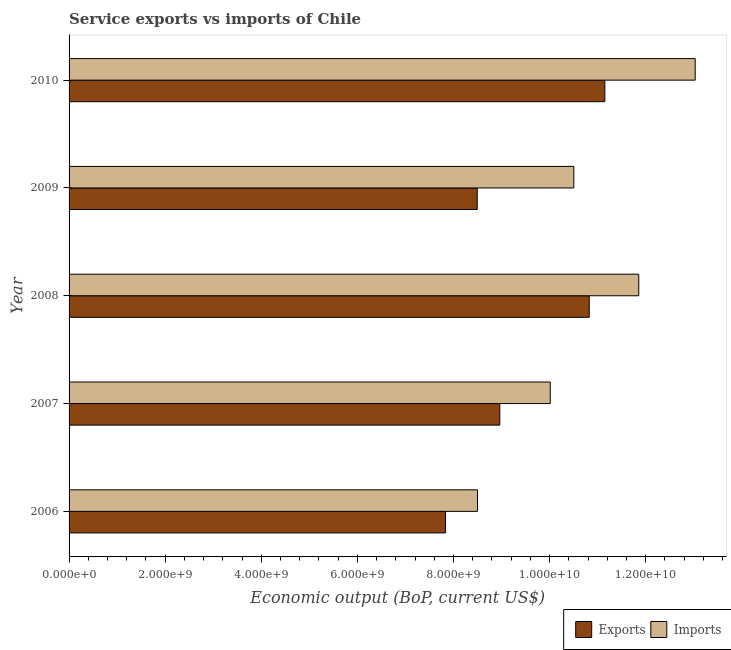Are the number of bars per tick equal to the number of legend labels?
Your response must be concise. Yes. What is the label of the 4th group of bars from the top?
Provide a succinct answer. 2007. What is the amount of service imports in 2007?
Your response must be concise. 1.00e+1. Across all years, what is the maximum amount of service exports?
Keep it short and to the point. 1.11e+1. Across all years, what is the minimum amount of service imports?
Offer a very short reply. 8.50e+09. In which year was the amount of service imports minimum?
Make the answer very short. 2006. What is the total amount of service imports in the graph?
Provide a short and direct response. 5.39e+1. What is the difference between the amount of service imports in 2006 and that in 2007?
Ensure brevity in your answer.  -1.51e+09. What is the difference between the amount of service exports in 2008 and the amount of service imports in 2007?
Your answer should be compact. 8.11e+08. What is the average amount of service exports per year?
Offer a terse response. 9.45e+09. In the year 2009, what is the difference between the amount of service exports and amount of service imports?
Keep it short and to the point. -2.01e+09. What is the ratio of the amount of service exports in 2009 to that in 2010?
Make the answer very short. 0.76. Is the amount of service imports in 2008 less than that in 2010?
Give a very brief answer. Yes. What is the difference between the highest and the second highest amount of service exports?
Provide a succinct answer. 3.25e+08. What is the difference between the highest and the lowest amount of service exports?
Keep it short and to the point. 3.32e+09. In how many years, is the amount of service imports greater than the average amount of service imports taken over all years?
Provide a succinct answer. 2. Is the sum of the amount of service imports in 2008 and 2009 greater than the maximum amount of service exports across all years?
Your response must be concise. Yes. What does the 2nd bar from the top in 2007 represents?
Offer a very short reply. Exports. What does the 1st bar from the bottom in 2008 represents?
Ensure brevity in your answer.  Exports. How many bars are there?
Your answer should be very brief. 10. What is the difference between two consecutive major ticks on the X-axis?
Your response must be concise. 2.00e+09. Does the graph contain any zero values?
Ensure brevity in your answer.  No. Where does the legend appear in the graph?
Your answer should be compact. Bottom right. What is the title of the graph?
Provide a succinct answer. Service exports vs imports of Chile. What is the label or title of the X-axis?
Your response must be concise. Economic output (BoP, current US$). What is the Economic output (BoP, current US$) of Exports in 2006?
Your response must be concise. 7.83e+09. What is the Economic output (BoP, current US$) of Imports in 2006?
Keep it short and to the point. 8.50e+09. What is the Economic output (BoP, current US$) of Exports in 2007?
Your answer should be compact. 8.96e+09. What is the Economic output (BoP, current US$) in Imports in 2007?
Your response must be concise. 1.00e+1. What is the Economic output (BoP, current US$) in Exports in 2008?
Offer a terse response. 1.08e+1. What is the Economic output (BoP, current US$) in Imports in 2008?
Your answer should be compact. 1.19e+1. What is the Economic output (BoP, current US$) of Exports in 2009?
Make the answer very short. 8.49e+09. What is the Economic output (BoP, current US$) of Imports in 2009?
Give a very brief answer. 1.05e+1. What is the Economic output (BoP, current US$) in Exports in 2010?
Offer a very short reply. 1.11e+1. What is the Economic output (BoP, current US$) in Imports in 2010?
Keep it short and to the point. 1.30e+1. Across all years, what is the maximum Economic output (BoP, current US$) in Exports?
Make the answer very short. 1.11e+1. Across all years, what is the maximum Economic output (BoP, current US$) in Imports?
Give a very brief answer. 1.30e+1. Across all years, what is the minimum Economic output (BoP, current US$) of Exports?
Make the answer very short. 7.83e+09. Across all years, what is the minimum Economic output (BoP, current US$) in Imports?
Offer a terse response. 8.50e+09. What is the total Economic output (BoP, current US$) of Exports in the graph?
Provide a short and direct response. 4.73e+1. What is the total Economic output (BoP, current US$) of Imports in the graph?
Your answer should be compact. 5.39e+1. What is the difference between the Economic output (BoP, current US$) of Exports in 2006 and that in 2007?
Your answer should be compact. -1.13e+09. What is the difference between the Economic output (BoP, current US$) of Imports in 2006 and that in 2007?
Provide a succinct answer. -1.51e+09. What is the difference between the Economic output (BoP, current US$) of Exports in 2006 and that in 2008?
Keep it short and to the point. -2.99e+09. What is the difference between the Economic output (BoP, current US$) of Imports in 2006 and that in 2008?
Provide a succinct answer. -3.36e+09. What is the difference between the Economic output (BoP, current US$) in Exports in 2006 and that in 2009?
Give a very brief answer. -6.61e+08. What is the difference between the Economic output (BoP, current US$) of Imports in 2006 and that in 2009?
Offer a terse response. -2.00e+09. What is the difference between the Economic output (BoP, current US$) of Exports in 2006 and that in 2010?
Ensure brevity in your answer.  -3.32e+09. What is the difference between the Economic output (BoP, current US$) of Imports in 2006 and that in 2010?
Your answer should be compact. -4.53e+09. What is the difference between the Economic output (BoP, current US$) in Exports in 2007 and that in 2008?
Keep it short and to the point. -1.86e+09. What is the difference between the Economic output (BoP, current US$) in Imports in 2007 and that in 2008?
Ensure brevity in your answer.  -1.84e+09. What is the difference between the Economic output (BoP, current US$) in Exports in 2007 and that in 2009?
Your response must be concise. 4.70e+08. What is the difference between the Economic output (BoP, current US$) in Imports in 2007 and that in 2009?
Offer a very short reply. -4.91e+08. What is the difference between the Economic output (BoP, current US$) of Exports in 2007 and that in 2010?
Offer a very short reply. -2.19e+09. What is the difference between the Economic output (BoP, current US$) in Imports in 2007 and that in 2010?
Provide a succinct answer. -3.02e+09. What is the difference between the Economic output (BoP, current US$) in Exports in 2008 and that in 2009?
Keep it short and to the point. 2.33e+09. What is the difference between the Economic output (BoP, current US$) of Imports in 2008 and that in 2009?
Keep it short and to the point. 1.35e+09. What is the difference between the Economic output (BoP, current US$) of Exports in 2008 and that in 2010?
Your answer should be compact. -3.25e+08. What is the difference between the Economic output (BoP, current US$) in Imports in 2008 and that in 2010?
Offer a very short reply. -1.17e+09. What is the difference between the Economic output (BoP, current US$) in Exports in 2009 and that in 2010?
Provide a short and direct response. -2.66e+09. What is the difference between the Economic output (BoP, current US$) in Imports in 2009 and that in 2010?
Provide a short and direct response. -2.53e+09. What is the difference between the Economic output (BoP, current US$) in Exports in 2006 and the Economic output (BoP, current US$) in Imports in 2007?
Offer a very short reply. -2.18e+09. What is the difference between the Economic output (BoP, current US$) in Exports in 2006 and the Economic output (BoP, current US$) in Imports in 2008?
Your answer should be very brief. -4.02e+09. What is the difference between the Economic output (BoP, current US$) of Exports in 2006 and the Economic output (BoP, current US$) of Imports in 2009?
Give a very brief answer. -2.67e+09. What is the difference between the Economic output (BoP, current US$) of Exports in 2006 and the Economic output (BoP, current US$) of Imports in 2010?
Provide a succinct answer. -5.20e+09. What is the difference between the Economic output (BoP, current US$) in Exports in 2007 and the Economic output (BoP, current US$) in Imports in 2008?
Offer a very short reply. -2.89e+09. What is the difference between the Economic output (BoP, current US$) of Exports in 2007 and the Economic output (BoP, current US$) of Imports in 2009?
Offer a terse response. -1.54e+09. What is the difference between the Economic output (BoP, current US$) of Exports in 2007 and the Economic output (BoP, current US$) of Imports in 2010?
Provide a short and direct response. -4.07e+09. What is the difference between the Economic output (BoP, current US$) in Exports in 2008 and the Economic output (BoP, current US$) in Imports in 2009?
Provide a succinct answer. 3.21e+08. What is the difference between the Economic output (BoP, current US$) in Exports in 2008 and the Economic output (BoP, current US$) in Imports in 2010?
Give a very brief answer. -2.20e+09. What is the difference between the Economic output (BoP, current US$) in Exports in 2009 and the Economic output (BoP, current US$) in Imports in 2010?
Your answer should be compact. -4.54e+09. What is the average Economic output (BoP, current US$) of Exports per year?
Your answer should be compact. 9.45e+09. What is the average Economic output (BoP, current US$) of Imports per year?
Provide a short and direct response. 1.08e+1. In the year 2006, what is the difference between the Economic output (BoP, current US$) in Exports and Economic output (BoP, current US$) in Imports?
Your response must be concise. -6.66e+08. In the year 2007, what is the difference between the Economic output (BoP, current US$) in Exports and Economic output (BoP, current US$) in Imports?
Ensure brevity in your answer.  -1.05e+09. In the year 2008, what is the difference between the Economic output (BoP, current US$) of Exports and Economic output (BoP, current US$) of Imports?
Offer a terse response. -1.03e+09. In the year 2009, what is the difference between the Economic output (BoP, current US$) of Exports and Economic output (BoP, current US$) of Imports?
Your response must be concise. -2.01e+09. In the year 2010, what is the difference between the Economic output (BoP, current US$) in Exports and Economic output (BoP, current US$) in Imports?
Keep it short and to the point. -1.88e+09. What is the ratio of the Economic output (BoP, current US$) in Exports in 2006 to that in 2007?
Offer a terse response. 0.87. What is the ratio of the Economic output (BoP, current US$) in Imports in 2006 to that in 2007?
Your answer should be very brief. 0.85. What is the ratio of the Economic output (BoP, current US$) of Exports in 2006 to that in 2008?
Provide a succinct answer. 0.72. What is the ratio of the Economic output (BoP, current US$) of Imports in 2006 to that in 2008?
Your answer should be very brief. 0.72. What is the ratio of the Economic output (BoP, current US$) in Exports in 2006 to that in 2009?
Your answer should be compact. 0.92. What is the ratio of the Economic output (BoP, current US$) in Imports in 2006 to that in 2009?
Your answer should be very brief. 0.81. What is the ratio of the Economic output (BoP, current US$) of Exports in 2006 to that in 2010?
Your response must be concise. 0.7. What is the ratio of the Economic output (BoP, current US$) in Imports in 2006 to that in 2010?
Your response must be concise. 0.65. What is the ratio of the Economic output (BoP, current US$) of Exports in 2007 to that in 2008?
Give a very brief answer. 0.83. What is the ratio of the Economic output (BoP, current US$) of Imports in 2007 to that in 2008?
Provide a short and direct response. 0.84. What is the ratio of the Economic output (BoP, current US$) of Exports in 2007 to that in 2009?
Your answer should be compact. 1.06. What is the ratio of the Economic output (BoP, current US$) in Imports in 2007 to that in 2009?
Ensure brevity in your answer.  0.95. What is the ratio of the Economic output (BoP, current US$) of Exports in 2007 to that in 2010?
Your answer should be very brief. 0.8. What is the ratio of the Economic output (BoP, current US$) in Imports in 2007 to that in 2010?
Provide a succinct answer. 0.77. What is the ratio of the Economic output (BoP, current US$) in Exports in 2008 to that in 2009?
Your answer should be compact. 1.27. What is the ratio of the Economic output (BoP, current US$) in Imports in 2008 to that in 2009?
Your response must be concise. 1.13. What is the ratio of the Economic output (BoP, current US$) in Exports in 2008 to that in 2010?
Your answer should be compact. 0.97. What is the ratio of the Economic output (BoP, current US$) in Imports in 2008 to that in 2010?
Offer a very short reply. 0.91. What is the ratio of the Economic output (BoP, current US$) in Exports in 2009 to that in 2010?
Offer a very short reply. 0.76. What is the ratio of the Economic output (BoP, current US$) in Imports in 2009 to that in 2010?
Your response must be concise. 0.81. What is the difference between the highest and the second highest Economic output (BoP, current US$) of Exports?
Keep it short and to the point. 3.25e+08. What is the difference between the highest and the second highest Economic output (BoP, current US$) in Imports?
Offer a very short reply. 1.17e+09. What is the difference between the highest and the lowest Economic output (BoP, current US$) of Exports?
Offer a very short reply. 3.32e+09. What is the difference between the highest and the lowest Economic output (BoP, current US$) in Imports?
Offer a very short reply. 4.53e+09. 